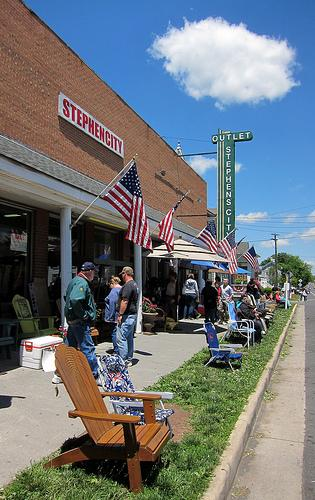What is the main seating object presented in the image? A wooden lounge chair on the grass. Can you describe the sentiment or atmosphere of the image based on the objects present? The image has a relaxed and laid-back atmosphere, with multiple chairs, American flags, and a blue sky with a puffy cloud. What is the color of the cooler on the ground, and where is it located within the image? The cooler is white, and it is located near the green chair. List 3 objects associated with the American flag in the image. Store sign, large beige umbrella, and above the man. Where is the white cooler located and what stands out about its handle? The white cooler is near the green chair with an orange handle. Can you describe the appearance of the sky, and mention one other object that is found in it? It is a blue sky with a large white puffy cloud. What color is the hat that the man is wearing, and where is he standing in relation to the store sign? The man is wearing a blue hat and standing below the store sign with an American flag. List two types of seating objects you can see on the grass in the image. A wooden lounge chair and a blue folding beach chair. How many lawn chairs are present in the image and describe their colors? Three lawn chairs are present, a brown wooden chair, a blue chair near the street, and a light blue chair. What type of athletic uniform is the subject wearing, and how does it look on multiple subjects? The subjects are wearing red jerseys on baseball players, with varying sizes and positions. Describe the lawn chairs on the side of the road. There are multiple lawn chairs, including a white and blue one, a blue one, a light blue one, and wooden brown ones. Give a detailed description of the image, including the location of the objects and their appearances. Wooden lounge chairs on grass, a man with a blue hat, American flags near a store, a white cooler, a large white cloud in the sky, various people in red jerseys, and a blue folding chair on the ground. List the objects present in the picture that have the color red. American flags, red jerseys on baseball players, "Stephencity" in red lettering Does the image contain an American flag above a man, a white cooler near a green chair, or a large white puffy cloud in the blue sky? Choose the correct option. A large white puffy cloud in the blue sky What type of grass field is mentioned in the image? Many grass on the field Identify any person's attire mentioned in the image. Man wearing a blue hat, she wears blue jeans Explain the location and appearance of the American flags in the image. American flags are hanging from a building, near a large beige umbrella, and on the side of a building. Can you identify the color of the sky and the presence of any clouds? Blue sky with a large white cloud What does the white sign on the window say? Unable to determine from the provided information Combine the elements present in the image to create a story or an event. At a patriotic baseball game in a small town, spectators gathered with their lawn chairs, coolers, and American flags to witness the action and enjoy the outdoors under the blue sky. What is the color of the lawn chair on the grass? Wooden, Brown What is the color combination of a lawn chair near the street? Blue Is there a wooden chair mentioned in the image? If so, what is its color? Yes, it is brown Describe the scene in the image in a poetic manner, including details about the sky, the grass, and the colors of the objects. Under a vast blue sky adorned with a white cloud, lies verdant grass with wooden chairs brown, red jerseys abound, and a man in a blue hat walks, patriotically crowned. Can you spot any flowers in the image? If yes, where? Yes, flowers in a planter Based on the objects present in the image, can you identify any event taking place? Possibly a baseball game, or a patriotic event. Are there any visible signs or text in the image? If so, provide the details of their colors and possible content. White sign on window (content unknown), "Stephencity" in red lettering Which emotion is expressed by the man wearing a blue hat? Not specified 